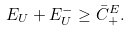Convert formula to latex. <formula><loc_0><loc_0><loc_500><loc_500>E _ { U } + E _ { U } ^ { - } \geq \bar { C } _ { + } ^ { E } .</formula> 